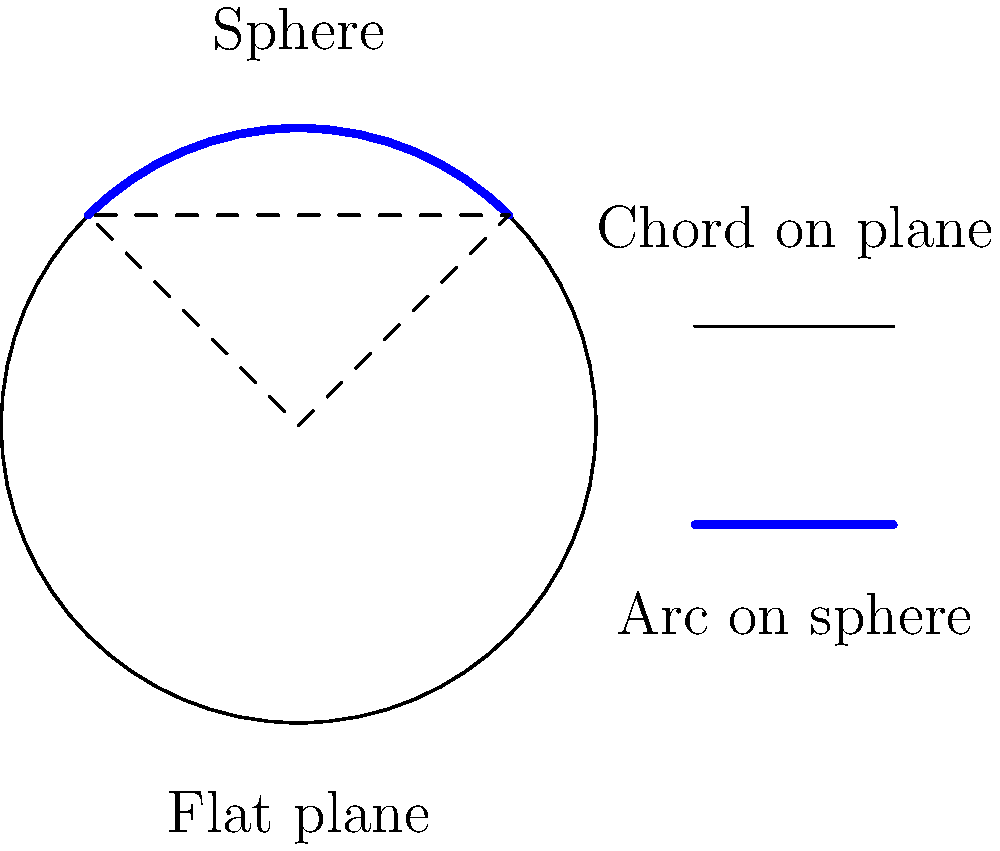As we practice our speech exercises together, let's explore an interesting geometric concept! Imagine we have a circle with radius $R$ on a flat plane and on the surface of a sphere with the same radius $R$. If we draw an arc on both surfaces that subtends an angle $\theta$ at the center, how does the area of the circular sector on the sphere compare to the area of the circular sector on the flat plane? Express your answer as a ratio of the spherical sector area to the planar sector area. Let's approach this step-by-step:

1) On a flat plane, the area of a circular sector is given by:
   $$A_{plane} = \frac{1}{2}R^2\theta$$
   where $\theta$ is in radians.

2) On a sphere, the area of a circular sector (spherical cap) is given by:
   $$A_{sphere} = 2\pi R^2\left(1 - \cos\frac{\theta}{2}\right)$$

3) To compare these, we need to find the ratio:
   $$\frac{A_{sphere}}{A_{plane}} = \frac{2\pi R^2\left(1 - \cos\frac{\theta}{2}\right)}{\frac{1}{2}R^2\theta}$$

4) The $R^2$ cancels out:
   $$\frac{A_{sphere}}{A_{plane}} = \frac{4\pi\left(1 - \cos\frac{\theta}{2}\right)}{\theta}$$

5) This ratio is always greater than 1 for $\theta > 0$, meaning the spherical sector has a larger area than the planar sector for the same central angle.

6) As $\theta$ approaches 0, the ratio approaches 1, meaning for very small angles, the areas are nearly the same.

7) As $\theta$ approaches $2\pi$ (a full circle), the ratio approaches 2, meaning a full hemisphere has twice the area of a full circle with the same radius.
Answer: $\frac{A_{sphere}}{A_{plane}} = \frac{4\pi\left(1 - \cos\frac{\theta}{2}\right)}{\theta}$ 